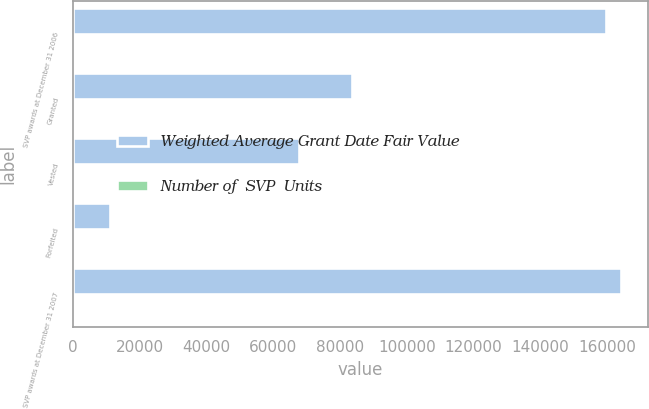Convert chart. <chart><loc_0><loc_0><loc_500><loc_500><stacked_bar_chart><ecel><fcel>SVP awards at December 31 2006<fcel>Granted<fcel>Vested<fcel>Forfeited<fcel>SVP awards at December 31 2007<nl><fcel>Weighted Average Grant Date Fair Value<fcel>159634<fcel>83580<fcel>67845<fcel>11189<fcel>164180<nl><fcel>Number of  SVP  Units<fcel>32.63<fcel>46.49<fcel>30.64<fcel>37.19<fcel>40.2<nl></chart> 